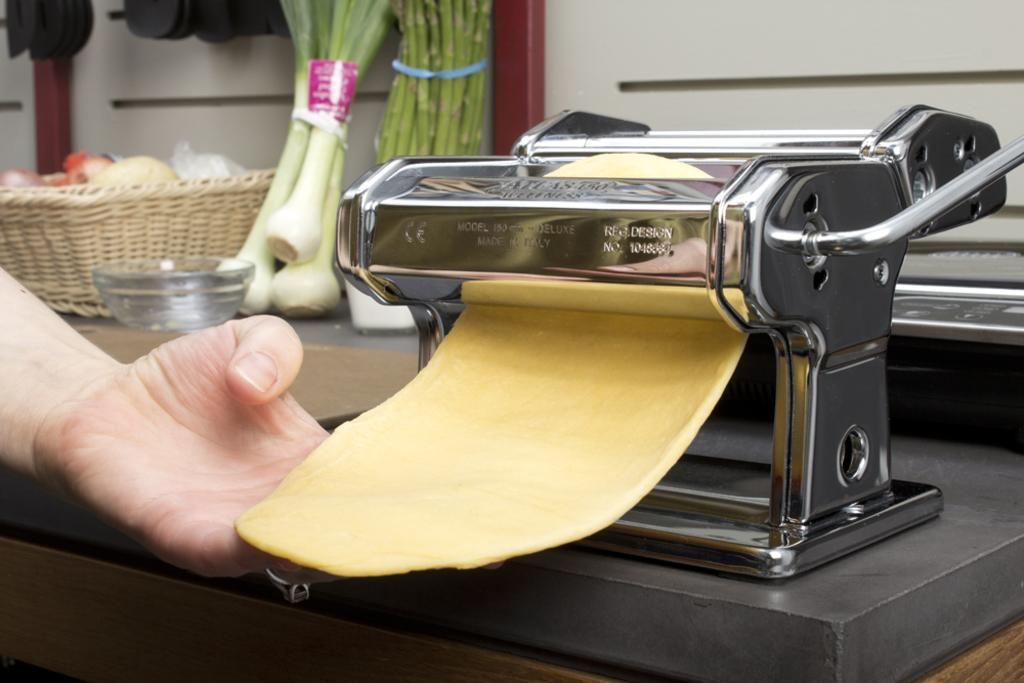<image>
Provide a brief description of the given image. A metal pasta roller that is rolling out dough is stamped with REG.DESIGN on its front. 